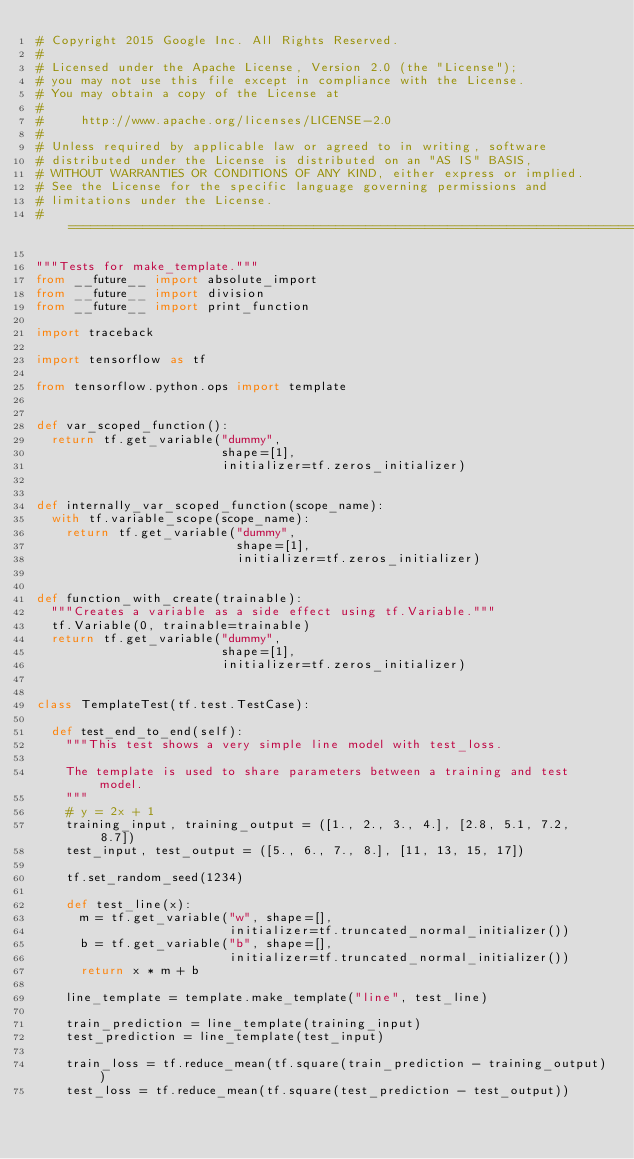<code> <loc_0><loc_0><loc_500><loc_500><_Python_># Copyright 2015 Google Inc. All Rights Reserved.
#
# Licensed under the Apache License, Version 2.0 (the "License");
# you may not use this file except in compliance with the License.
# You may obtain a copy of the License at
#
#     http://www.apache.org/licenses/LICENSE-2.0
#
# Unless required by applicable law or agreed to in writing, software
# distributed under the License is distributed on an "AS IS" BASIS,
# WITHOUT WARRANTIES OR CONDITIONS OF ANY KIND, either express or implied.
# See the License for the specific language governing permissions and
# limitations under the License.
# ==============================================================================

"""Tests for make_template."""
from __future__ import absolute_import
from __future__ import division
from __future__ import print_function

import traceback

import tensorflow as tf

from tensorflow.python.ops import template


def var_scoped_function():
  return tf.get_variable("dummy",
                         shape=[1],
                         initializer=tf.zeros_initializer)


def internally_var_scoped_function(scope_name):
  with tf.variable_scope(scope_name):
    return tf.get_variable("dummy",
                           shape=[1],
                           initializer=tf.zeros_initializer)


def function_with_create(trainable):
  """Creates a variable as a side effect using tf.Variable."""
  tf.Variable(0, trainable=trainable)
  return tf.get_variable("dummy",
                         shape=[1],
                         initializer=tf.zeros_initializer)


class TemplateTest(tf.test.TestCase):

  def test_end_to_end(self):
    """This test shows a very simple line model with test_loss.

    The template is used to share parameters between a training and test model.
    """
    # y = 2x + 1
    training_input, training_output = ([1., 2., 3., 4.], [2.8, 5.1, 7.2, 8.7])
    test_input, test_output = ([5., 6., 7., 8.], [11, 13, 15, 17])

    tf.set_random_seed(1234)

    def test_line(x):
      m = tf.get_variable("w", shape=[],
                          initializer=tf.truncated_normal_initializer())
      b = tf.get_variable("b", shape=[],
                          initializer=tf.truncated_normal_initializer())
      return x * m + b

    line_template = template.make_template("line", test_line)

    train_prediction = line_template(training_input)
    test_prediction = line_template(test_input)

    train_loss = tf.reduce_mean(tf.square(train_prediction - training_output))
    test_loss = tf.reduce_mean(tf.square(test_prediction - test_output))
</code> 